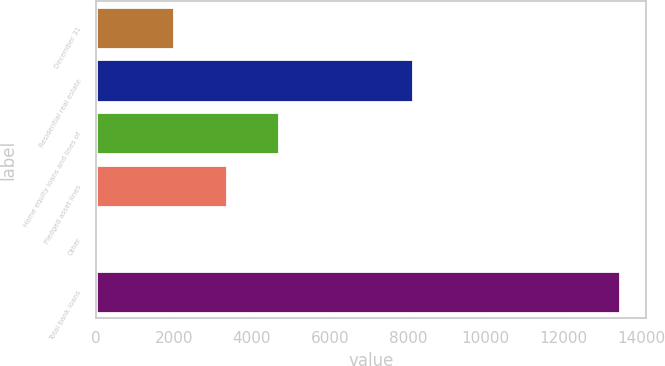Convert chart to OTSL. <chart><loc_0><loc_0><loc_500><loc_500><bar_chart><fcel>December 31<fcel>Residential real estate<fcel>Home equity loans and lines of<fcel>Pledged asset lines<fcel>Other<fcel>Total bank loans<nl><fcel>2014<fcel>8127<fcel>4694.4<fcel>3354.2<fcel>36<fcel>13438<nl></chart> 